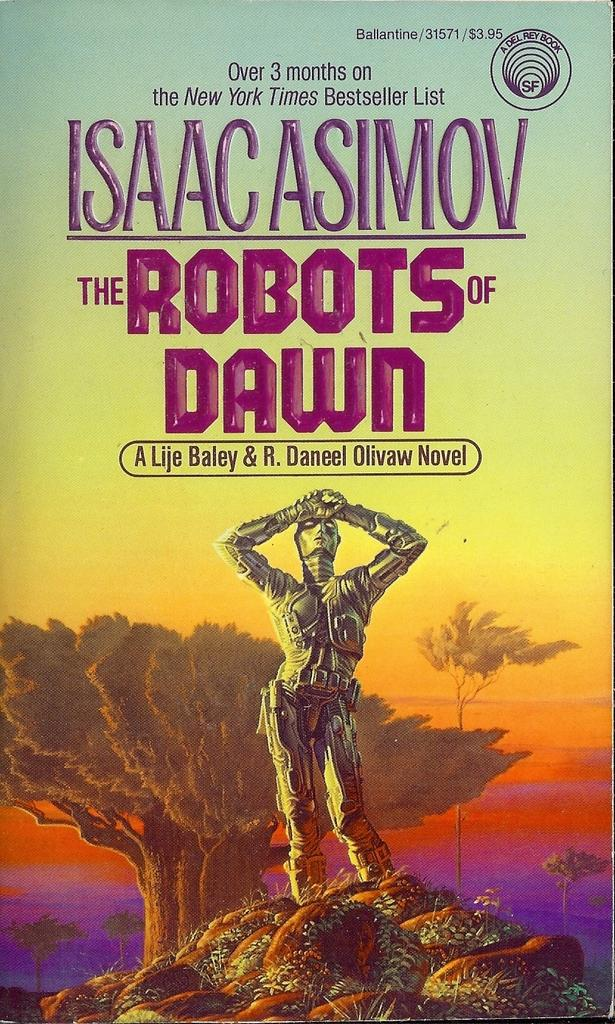Provide a one-sentence caption for the provided image. A book that was on the New York Times bestseller list for over 3 months. 